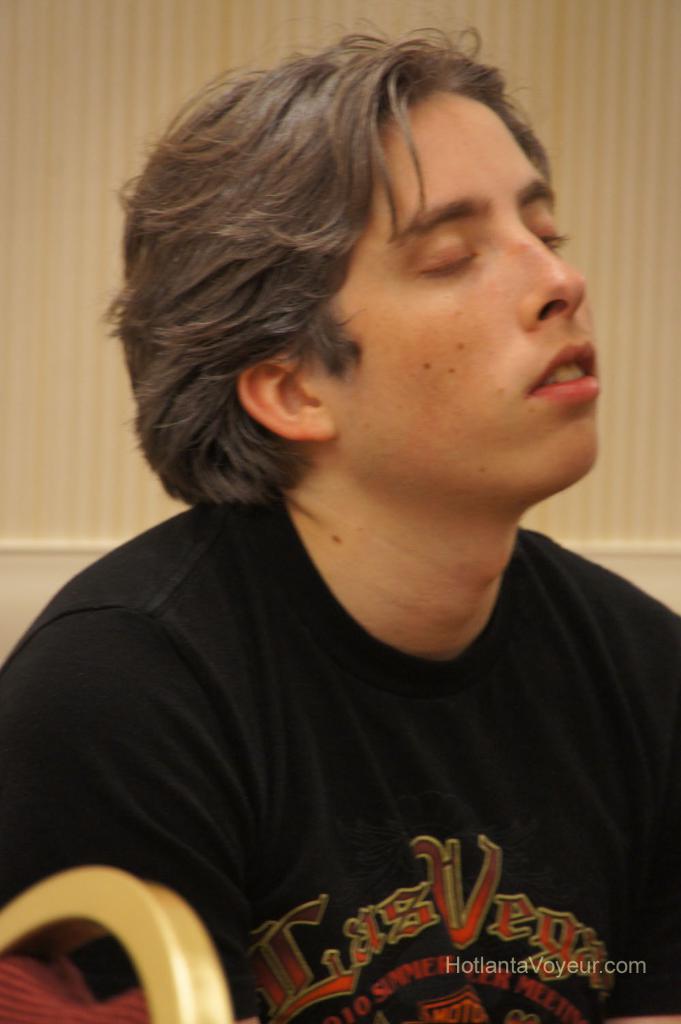In one or two sentences, can you explain what this image depicts? In this image there is a person. The person is closing the eyes. Behind the person there is a wall. In the bottom left there is an edge of a chair. In the bottom right there is text on the image. 